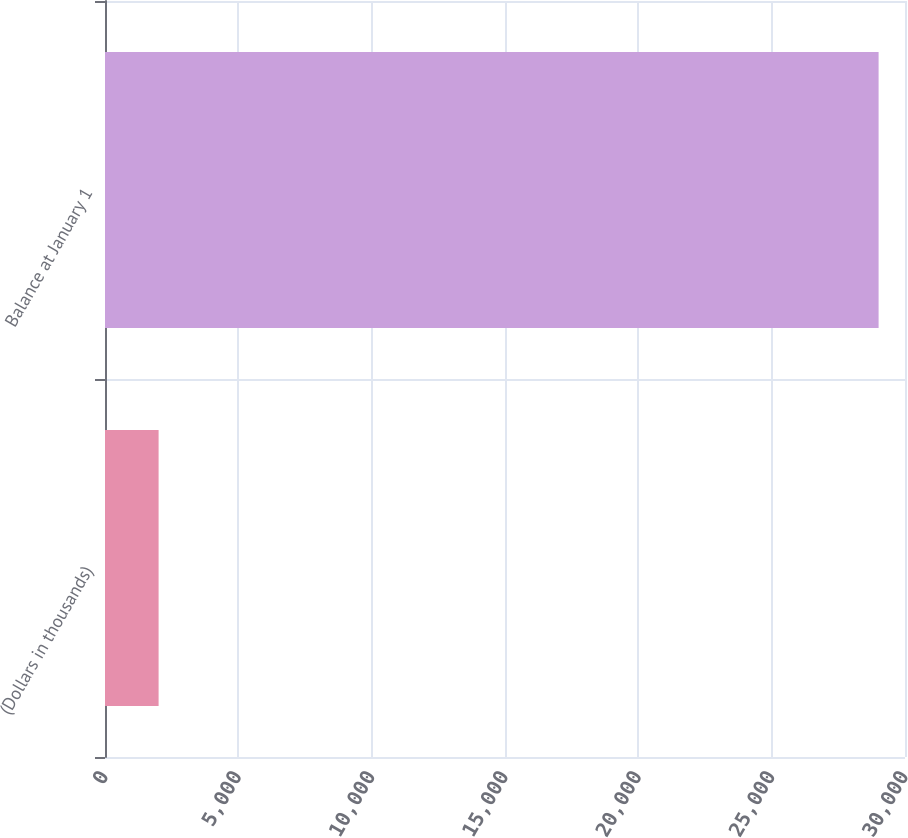Convert chart to OTSL. <chart><loc_0><loc_0><loc_500><loc_500><bar_chart><fcel>(Dollars in thousands)<fcel>Balance at January 1<nl><fcel>2010<fcel>29010<nl></chart> 